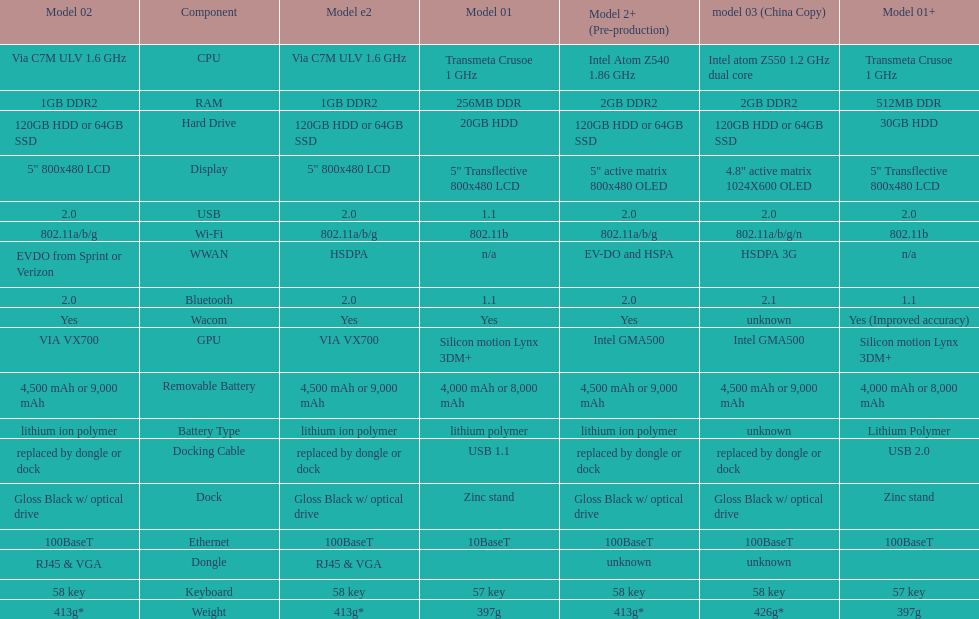How much heavier is the model 3 than the model 1? 29g. 